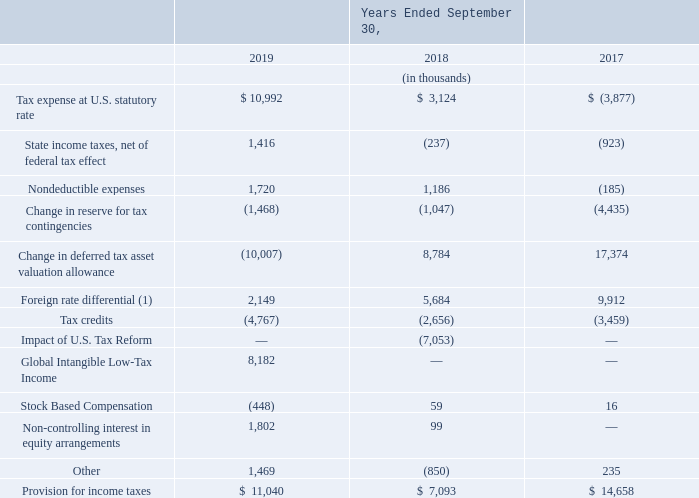The reconciliation of income tax computed at the U.S. federal statutory tax rate to income tax expense is as follows:
(1) In 2018, we recorded $3.5 million of tax expense related to foreign earnings which were not permanently reinvested prior to the enactment of the U.S. Tax Act. After enactment, certain foreign earnings are taxed at higher statutory rates than the U.S. which results in $2.1 million of incremental tax expense in 2019. In 2017, we provided for deferred taxes on all cumulative unremitted foreign earnings, as the earnings were no longer considered permanently reinvested resulting in a charge of $9.5 million.
What does the table show? Reconciliation of income tax computed at the u.s. federal statutory tax rate to income tax expense. What is the Tax expense at U.S. statutory rate for 2019?
Answer scale should be: thousand. $ 10,992. For which years was the reconciliation of income tax computed at the U.S. federal statutory tax rate to income tax expense provided? 2019, 2018, 2017. In which year was the provision for income taxes the largest? 14,658>11,040>7,093
Answer: 2017. What is the change in nondeductible expenses in 2019 from 2018?
Answer scale should be: thousand. 1,720-1,186
Answer: 534. What is the percentage change in nondeductible expenses in 2019 from 2018?
Answer scale should be: percent. (1,720-1,186)/1,186
Answer: 45.03. 